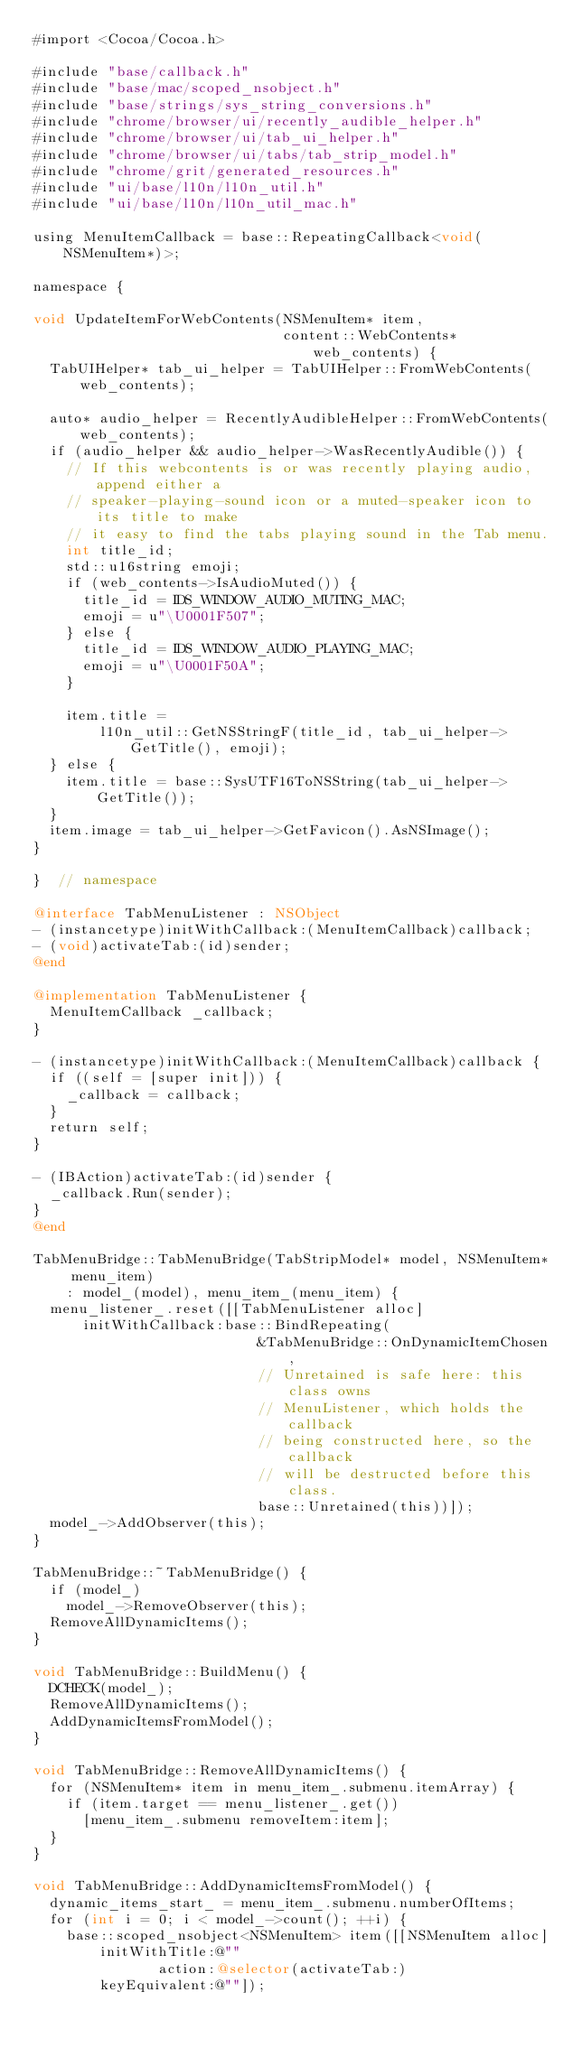<code> <loc_0><loc_0><loc_500><loc_500><_ObjectiveC_>#import <Cocoa/Cocoa.h>

#include "base/callback.h"
#include "base/mac/scoped_nsobject.h"
#include "base/strings/sys_string_conversions.h"
#include "chrome/browser/ui/recently_audible_helper.h"
#include "chrome/browser/ui/tab_ui_helper.h"
#include "chrome/browser/ui/tabs/tab_strip_model.h"
#include "chrome/grit/generated_resources.h"
#include "ui/base/l10n/l10n_util.h"
#include "ui/base/l10n/l10n_util_mac.h"

using MenuItemCallback = base::RepeatingCallback<void(NSMenuItem*)>;

namespace {

void UpdateItemForWebContents(NSMenuItem* item,
                              content::WebContents* web_contents) {
  TabUIHelper* tab_ui_helper = TabUIHelper::FromWebContents(web_contents);

  auto* audio_helper = RecentlyAudibleHelper::FromWebContents(web_contents);
  if (audio_helper && audio_helper->WasRecentlyAudible()) {
    // If this webcontents is or was recently playing audio, append either a
    // speaker-playing-sound icon or a muted-speaker icon to its title to make
    // it easy to find the tabs playing sound in the Tab menu.
    int title_id;
    std::u16string emoji;
    if (web_contents->IsAudioMuted()) {
      title_id = IDS_WINDOW_AUDIO_MUTING_MAC;
      emoji = u"\U0001F507";
    } else {
      title_id = IDS_WINDOW_AUDIO_PLAYING_MAC;
      emoji = u"\U0001F50A";
    }

    item.title =
        l10n_util::GetNSStringF(title_id, tab_ui_helper->GetTitle(), emoji);
  } else {
    item.title = base::SysUTF16ToNSString(tab_ui_helper->GetTitle());
  }
  item.image = tab_ui_helper->GetFavicon().AsNSImage();
}

}  // namespace

@interface TabMenuListener : NSObject
- (instancetype)initWithCallback:(MenuItemCallback)callback;
- (void)activateTab:(id)sender;
@end

@implementation TabMenuListener {
  MenuItemCallback _callback;
}

- (instancetype)initWithCallback:(MenuItemCallback)callback {
  if ((self = [super init])) {
    _callback = callback;
  }
  return self;
}

- (IBAction)activateTab:(id)sender {
  _callback.Run(sender);
}
@end

TabMenuBridge::TabMenuBridge(TabStripModel* model, NSMenuItem* menu_item)
    : model_(model), menu_item_(menu_item) {
  menu_listener_.reset([[TabMenuListener alloc]
      initWithCallback:base::BindRepeating(
                           &TabMenuBridge::OnDynamicItemChosen,
                           // Unretained is safe here: this class owns
                           // MenuListener, which holds the callback
                           // being constructed here, so the callback
                           // will be destructed before this class.
                           base::Unretained(this))]);
  model_->AddObserver(this);
}

TabMenuBridge::~TabMenuBridge() {
  if (model_)
    model_->RemoveObserver(this);
  RemoveAllDynamicItems();
}

void TabMenuBridge::BuildMenu() {
  DCHECK(model_);
  RemoveAllDynamicItems();
  AddDynamicItemsFromModel();
}

void TabMenuBridge::RemoveAllDynamicItems() {
  for (NSMenuItem* item in menu_item_.submenu.itemArray) {
    if (item.target == menu_listener_.get())
      [menu_item_.submenu removeItem:item];
  }
}

void TabMenuBridge::AddDynamicItemsFromModel() {
  dynamic_items_start_ = menu_item_.submenu.numberOfItems;
  for (int i = 0; i < model_->count(); ++i) {
    base::scoped_nsobject<NSMenuItem> item([[NSMenuItem alloc]
        initWithTitle:@""
               action:@selector(activateTab:)
        keyEquivalent:@""]);</code> 